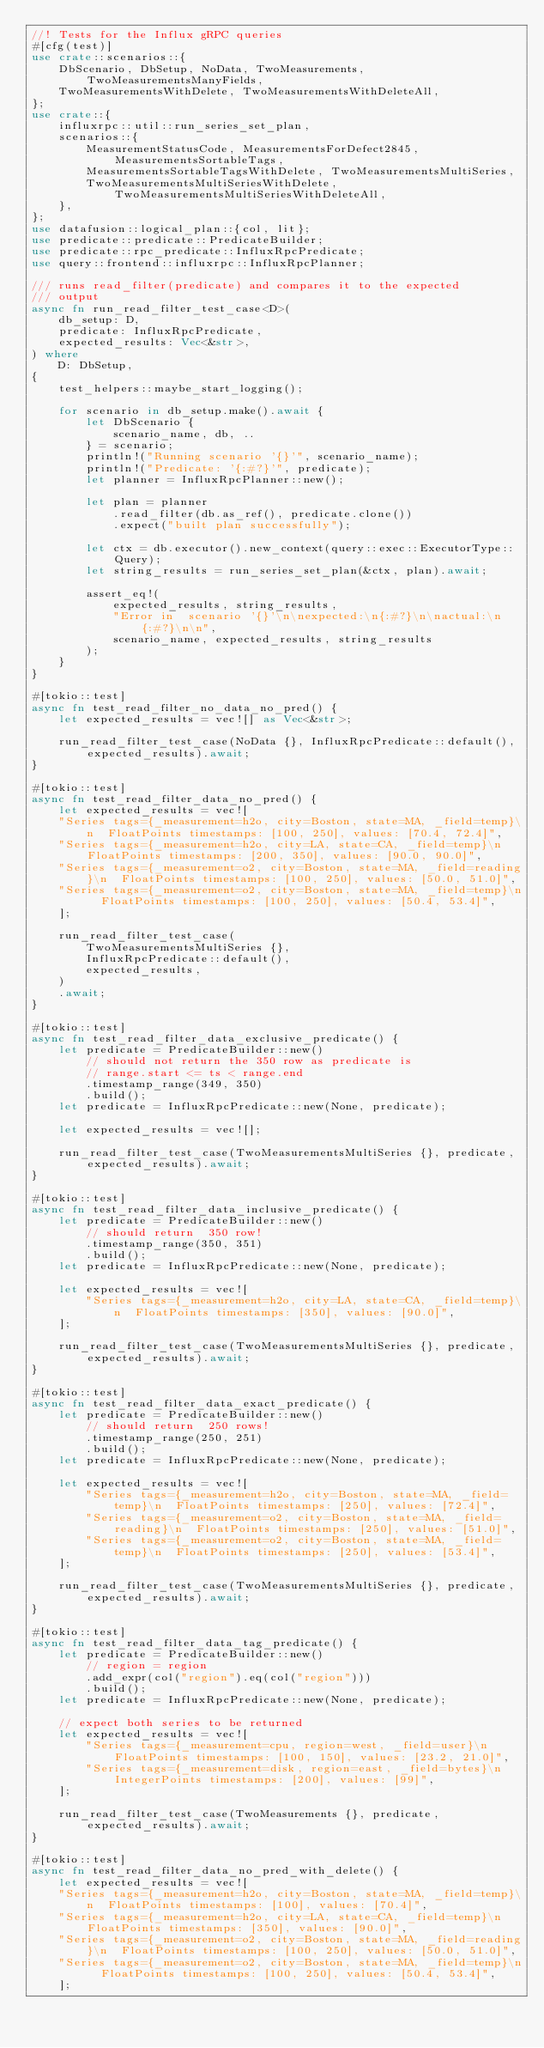<code> <loc_0><loc_0><loc_500><loc_500><_Rust_>//! Tests for the Influx gRPC queries
#[cfg(test)]
use crate::scenarios::{
    DbScenario, DbSetup, NoData, TwoMeasurements, TwoMeasurementsManyFields,
    TwoMeasurementsWithDelete, TwoMeasurementsWithDeleteAll,
};
use crate::{
    influxrpc::util::run_series_set_plan,
    scenarios::{
        MeasurementStatusCode, MeasurementsForDefect2845, MeasurementsSortableTags,
        MeasurementsSortableTagsWithDelete, TwoMeasurementsMultiSeries,
        TwoMeasurementsMultiSeriesWithDelete, TwoMeasurementsMultiSeriesWithDeleteAll,
    },
};
use datafusion::logical_plan::{col, lit};
use predicate::predicate::PredicateBuilder;
use predicate::rpc_predicate::InfluxRpcPredicate;
use query::frontend::influxrpc::InfluxRpcPlanner;

/// runs read_filter(predicate) and compares it to the expected
/// output
async fn run_read_filter_test_case<D>(
    db_setup: D,
    predicate: InfluxRpcPredicate,
    expected_results: Vec<&str>,
) where
    D: DbSetup,
{
    test_helpers::maybe_start_logging();

    for scenario in db_setup.make().await {
        let DbScenario {
            scenario_name, db, ..
        } = scenario;
        println!("Running scenario '{}'", scenario_name);
        println!("Predicate: '{:#?}'", predicate);
        let planner = InfluxRpcPlanner::new();

        let plan = planner
            .read_filter(db.as_ref(), predicate.clone())
            .expect("built plan successfully");

        let ctx = db.executor().new_context(query::exec::ExecutorType::Query);
        let string_results = run_series_set_plan(&ctx, plan).await;

        assert_eq!(
            expected_results, string_results,
            "Error in  scenario '{}'\n\nexpected:\n{:#?}\n\nactual:\n{:#?}\n\n",
            scenario_name, expected_results, string_results
        );
    }
}

#[tokio::test]
async fn test_read_filter_no_data_no_pred() {
    let expected_results = vec![] as Vec<&str>;

    run_read_filter_test_case(NoData {}, InfluxRpcPredicate::default(), expected_results).await;
}

#[tokio::test]
async fn test_read_filter_data_no_pred() {
    let expected_results = vec![
    "Series tags={_measurement=h2o, city=Boston, state=MA, _field=temp}\n  FloatPoints timestamps: [100, 250], values: [70.4, 72.4]",
    "Series tags={_measurement=h2o, city=LA, state=CA, _field=temp}\n  FloatPoints timestamps: [200, 350], values: [90.0, 90.0]",
    "Series tags={_measurement=o2, city=Boston, state=MA, _field=reading}\n  FloatPoints timestamps: [100, 250], values: [50.0, 51.0]",
    "Series tags={_measurement=o2, city=Boston, state=MA, _field=temp}\n  FloatPoints timestamps: [100, 250], values: [50.4, 53.4]",
    ];

    run_read_filter_test_case(
        TwoMeasurementsMultiSeries {},
        InfluxRpcPredicate::default(),
        expected_results,
    )
    .await;
}

#[tokio::test]
async fn test_read_filter_data_exclusive_predicate() {
    let predicate = PredicateBuilder::new()
        // should not return the 350 row as predicate is
        // range.start <= ts < range.end
        .timestamp_range(349, 350)
        .build();
    let predicate = InfluxRpcPredicate::new(None, predicate);

    let expected_results = vec![];

    run_read_filter_test_case(TwoMeasurementsMultiSeries {}, predicate, expected_results).await;
}

#[tokio::test]
async fn test_read_filter_data_inclusive_predicate() {
    let predicate = PredicateBuilder::new()
        // should return  350 row!
        .timestamp_range(350, 351)
        .build();
    let predicate = InfluxRpcPredicate::new(None, predicate);

    let expected_results = vec![
        "Series tags={_measurement=h2o, city=LA, state=CA, _field=temp}\n  FloatPoints timestamps: [350], values: [90.0]",
    ];

    run_read_filter_test_case(TwoMeasurementsMultiSeries {}, predicate, expected_results).await;
}

#[tokio::test]
async fn test_read_filter_data_exact_predicate() {
    let predicate = PredicateBuilder::new()
        // should return  250 rows!
        .timestamp_range(250, 251)
        .build();
    let predicate = InfluxRpcPredicate::new(None, predicate);

    let expected_results = vec![
        "Series tags={_measurement=h2o, city=Boston, state=MA, _field=temp}\n  FloatPoints timestamps: [250], values: [72.4]",
        "Series tags={_measurement=o2, city=Boston, state=MA, _field=reading}\n  FloatPoints timestamps: [250], values: [51.0]",
        "Series tags={_measurement=o2, city=Boston, state=MA, _field=temp}\n  FloatPoints timestamps: [250], values: [53.4]",
    ];

    run_read_filter_test_case(TwoMeasurementsMultiSeries {}, predicate, expected_results).await;
}

#[tokio::test]
async fn test_read_filter_data_tag_predicate() {
    let predicate = PredicateBuilder::new()
        // region = region
        .add_expr(col("region").eq(col("region")))
        .build();
    let predicate = InfluxRpcPredicate::new(None, predicate);

    // expect both series to be returned
    let expected_results = vec![
        "Series tags={_measurement=cpu, region=west, _field=user}\n  FloatPoints timestamps: [100, 150], values: [23.2, 21.0]",
        "Series tags={_measurement=disk, region=east, _field=bytes}\n  IntegerPoints timestamps: [200], values: [99]",
    ];

    run_read_filter_test_case(TwoMeasurements {}, predicate, expected_results).await;
}

#[tokio::test]
async fn test_read_filter_data_no_pred_with_delete() {
    let expected_results = vec![
    "Series tags={_measurement=h2o, city=Boston, state=MA, _field=temp}\n  FloatPoints timestamps: [100], values: [70.4]",
    "Series tags={_measurement=h2o, city=LA, state=CA, _field=temp}\n  FloatPoints timestamps: [350], values: [90.0]",
    "Series tags={_measurement=o2, city=Boston, state=MA, _field=reading}\n  FloatPoints timestamps: [100, 250], values: [50.0, 51.0]",
    "Series tags={_measurement=o2, city=Boston, state=MA, _field=temp}\n  FloatPoints timestamps: [100, 250], values: [50.4, 53.4]",
    ];
</code> 